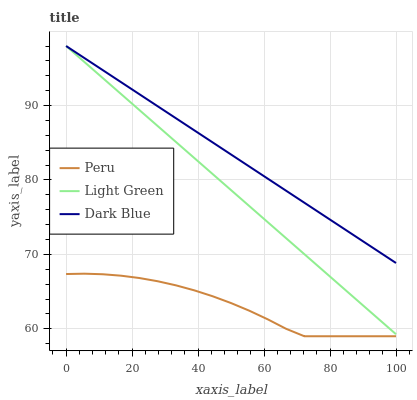Does Light Green have the minimum area under the curve?
Answer yes or no. No. Does Light Green have the maximum area under the curve?
Answer yes or no. No. Is Light Green the smoothest?
Answer yes or no. No. Is Light Green the roughest?
Answer yes or no. No. Does Light Green have the lowest value?
Answer yes or no. No. Does Peru have the highest value?
Answer yes or no. No. Is Peru less than Light Green?
Answer yes or no. Yes. Is Dark Blue greater than Peru?
Answer yes or no. Yes. Does Peru intersect Light Green?
Answer yes or no. No. 